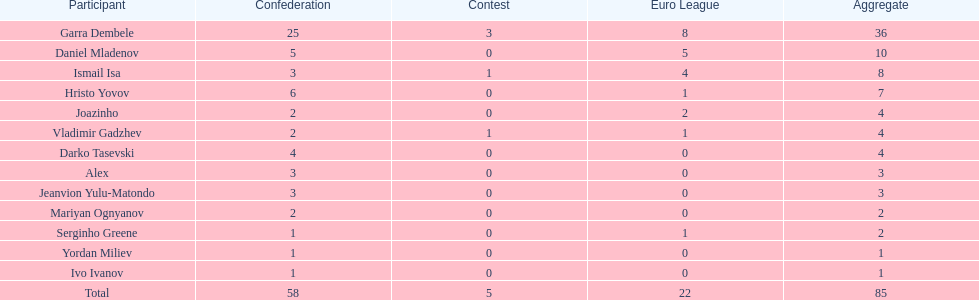How many goals did ismail isa score this season? 8. Could you help me parse every detail presented in this table? {'header': ['Participant', 'Confederation', 'Contest', 'Euro League', 'Aggregate'], 'rows': [['Garra Dembele', '25', '3', '8', '36'], ['Daniel Mladenov', '5', '0', '5', '10'], ['Ismail Isa', '3', '1', '4', '8'], ['Hristo Yovov', '6', '0', '1', '7'], ['Joazinho', '2', '0', '2', '4'], ['Vladimir Gadzhev', '2', '1', '1', '4'], ['Darko Tasevski', '4', '0', '0', '4'], ['Alex', '3', '0', '0', '3'], ['Jeanvion Yulu-Matondo', '3', '0', '0', '3'], ['Mariyan Ognyanov', '2', '0', '0', '2'], ['Serginho Greene', '1', '0', '1', '2'], ['Yordan Miliev', '1', '0', '0', '1'], ['Ivo Ivanov', '1', '0', '0', '1'], ['Total', '58', '5', '22', '85']]} 